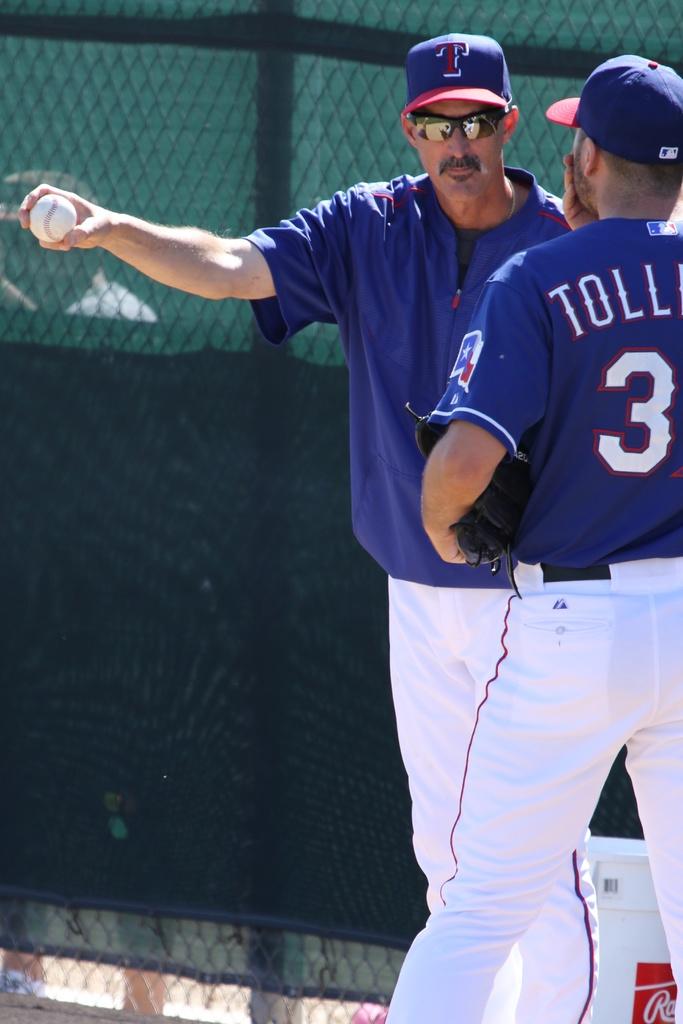What letter does the player's name start with, on the right?
Make the answer very short. T. What is the letter on the hat of the coach ?
Your answer should be compact. T. 